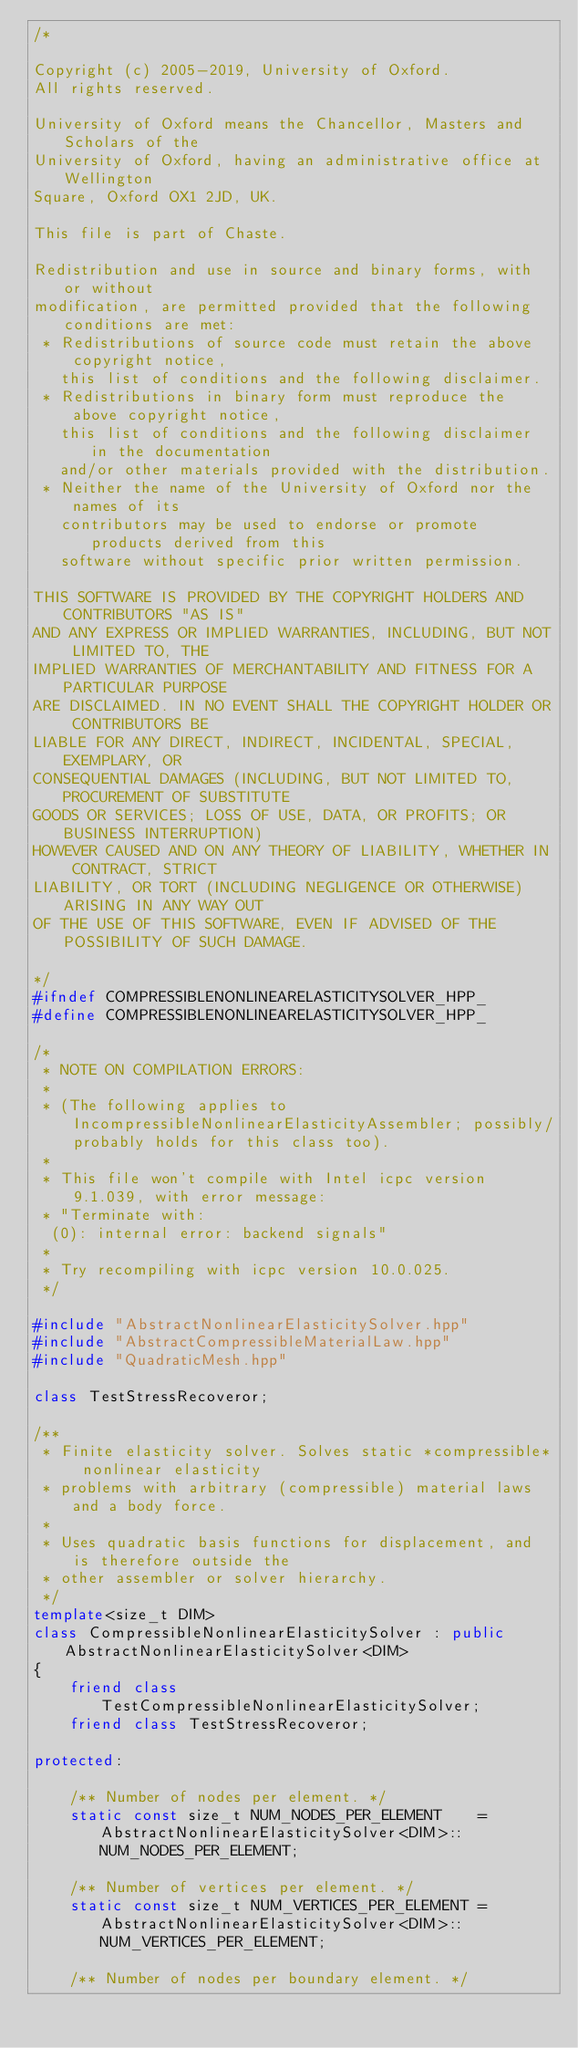Convert code to text. <code><loc_0><loc_0><loc_500><loc_500><_C++_>/*

Copyright (c) 2005-2019, University of Oxford.
All rights reserved.

University of Oxford means the Chancellor, Masters and Scholars of the
University of Oxford, having an administrative office at Wellington
Square, Oxford OX1 2JD, UK.

This file is part of Chaste.

Redistribution and use in source and binary forms, with or without
modification, are permitted provided that the following conditions are met:
 * Redistributions of source code must retain the above copyright notice,
   this list of conditions and the following disclaimer.
 * Redistributions in binary form must reproduce the above copyright notice,
   this list of conditions and the following disclaimer in the documentation
   and/or other materials provided with the distribution.
 * Neither the name of the University of Oxford nor the names of its
   contributors may be used to endorse or promote products derived from this
   software without specific prior written permission.

THIS SOFTWARE IS PROVIDED BY THE COPYRIGHT HOLDERS AND CONTRIBUTORS "AS IS"
AND ANY EXPRESS OR IMPLIED WARRANTIES, INCLUDING, BUT NOT LIMITED TO, THE
IMPLIED WARRANTIES OF MERCHANTABILITY AND FITNESS FOR A PARTICULAR PURPOSE
ARE DISCLAIMED. IN NO EVENT SHALL THE COPYRIGHT HOLDER OR CONTRIBUTORS BE
LIABLE FOR ANY DIRECT, INDIRECT, INCIDENTAL, SPECIAL, EXEMPLARY, OR
CONSEQUENTIAL DAMAGES (INCLUDING, BUT NOT LIMITED TO, PROCUREMENT OF SUBSTITUTE
GOODS OR SERVICES; LOSS OF USE, DATA, OR PROFITS; OR BUSINESS INTERRUPTION)
HOWEVER CAUSED AND ON ANY THEORY OF LIABILITY, WHETHER IN CONTRACT, STRICT
LIABILITY, OR TORT (INCLUDING NEGLIGENCE OR OTHERWISE) ARISING IN ANY WAY OUT
OF THE USE OF THIS SOFTWARE, EVEN IF ADVISED OF THE POSSIBILITY OF SUCH DAMAGE.

*/
#ifndef COMPRESSIBLENONLINEARELASTICITYSOLVER_HPP_
#define COMPRESSIBLENONLINEARELASTICITYSOLVER_HPP_

/*
 * NOTE ON COMPILATION ERRORS:
 *
 * (The following applies to IncompressibleNonlinearElasticityAssembler; possibly/probably holds for this class too).
 *
 * This file won't compile with Intel icpc version 9.1.039, with error message:
 * "Terminate with:
  (0): internal error: backend signals"
 *
 * Try recompiling with icpc version 10.0.025.
 */

#include "AbstractNonlinearElasticitySolver.hpp"
#include "AbstractCompressibleMaterialLaw.hpp"
#include "QuadraticMesh.hpp"

class TestStressRecoveror;

/**
 * Finite elasticity solver. Solves static *compressible* nonlinear elasticity
 * problems with arbitrary (compressible) material laws and a body force.
 *
 * Uses quadratic basis functions for displacement, and is therefore outside the
 * other assembler or solver hierarchy.
 */
template<size_t DIM>
class CompressibleNonlinearElasticitySolver : public AbstractNonlinearElasticitySolver<DIM>
{
    friend class TestCompressibleNonlinearElasticitySolver;
    friend class TestStressRecoveror;

protected:

    /** Number of nodes per element. */
    static const size_t NUM_NODES_PER_ELEMENT    = AbstractNonlinearElasticitySolver<DIM>::NUM_NODES_PER_ELEMENT;

    /** Number of vertices per element. */
    static const size_t NUM_VERTICES_PER_ELEMENT = AbstractNonlinearElasticitySolver<DIM>::NUM_VERTICES_PER_ELEMENT;

    /** Number of nodes per boundary element. */</code> 